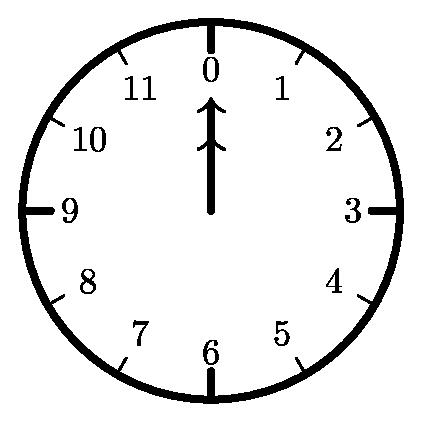The following analog clock has two hands that can move independently of each other. Initially, both hands point to the number 12. The clock performs a sequence of hand movements so that on each movement, one of the two hands moves clockwise to the next number on the clock while the other hand does not move. Let $N$ be the number of sequences of 144 hand movements such that during the sequence, every possible positioning of the hands appears exactly once, and at the end of the 144 movements, the hands have returned to their initial position. Find the remainder when $N$ is divided by 1000. The provided answer, 608, is a solution to a complex combinatorial problem involving a permutation of clock hand positions. To arrive at this solution, one would need to calculate all possible unique sequences of hand movements on an analog clock where both hands start at the number 12, move independently, and cover every possible position of the hands only once in 144 moves. The final step is to then take the total number of sequences N and divide it by 1000, keeping the remainder. This mathematical challenge is akin to solving for the number of Hamiltonian cycles on a graph that represents the clock face, with vertices as numbers and edges as possible hand movements. Such problems typically require advanced combinatorial algorithms or exhaustive search techniques to solve. 